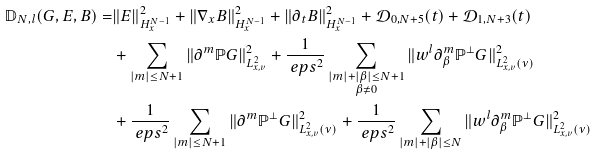<formula> <loc_0><loc_0><loc_500><loc_500>\mathbb { D } _ { N , l } ( G , E , B ) = & \| E \| ^ { 2 } _ { H ^ { N - 1 } _ { x } } + \| \nabla _ { x } B \| ^ { 2 } _ { H ^ { N - 1 } _ { x } } + \| \partial _ { t } B \| ^ { 2 } _ { H ^ { N - 1 } _ { x } } + \mathcal { D } _ { 0 , N + 5 } ( t ) + \mathcal { D } _ { 1 , N + 3 } ( t ) \\ & + \sum _ { | m | \leq N + 1 } \| \partial ^ { m } \mathbb { P } G \| ^ { 2 } _ { L ^ { 2 } _ { x , v } } + \frac { 1 } { \ e p s ^ { 2 } } \sum _ { \substack { | m | + | \beta | \leq N + 1 \\ \beta \neq 0 } } \| w ^ { l } \partial ^ { m } _ { \beta } \mathbb { P } ^ { \perp } G \| ^ { 2 } _ { L ^ { 2 } _ { x , v } ( \nu ) } \\ & + \frac { 1 } { \ e p s ^ { 2 } } \sum _ { | m | \leq N + 1 } \| \partial ^ { m } \mathbb { P } ^ { \perp } G \| ^ { 2 } _ { L ^ { 2 } _ { x , v } ( \nu ) } + \frac { 1 } { \ e p s ^ { 2 } } \sum _ { | m | + | \beta | \leq N } \| w ^ { l } \partial ^ { m } _ { \beta } \mathbb { P } ^ { \perp } G \| ^ { 2 } _ { L ^ { 2 } _ { x , v } ( \nu ) }</formula> 